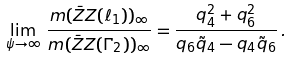<formula> <loc_0><loc_0><loc_500><loc_500>\lim _ { \psi \to \infty } \, \frac { \i m ( \bar { Z } Z ( \ell _ { 1 } ) ) _ { \infty } } { \i m ( \bar { Z } Z ( \Gamma _ { 2 } ) ) _ { \infty } } = \frac { q _ { 4 } ^ { 2 } + q _ { 6 } ^ { 2 } } { q _ { 6 } \tilde { q } _ { 4 } - q _ { 4 } \tilde { q } _ { 6 } } \, .</formula> 